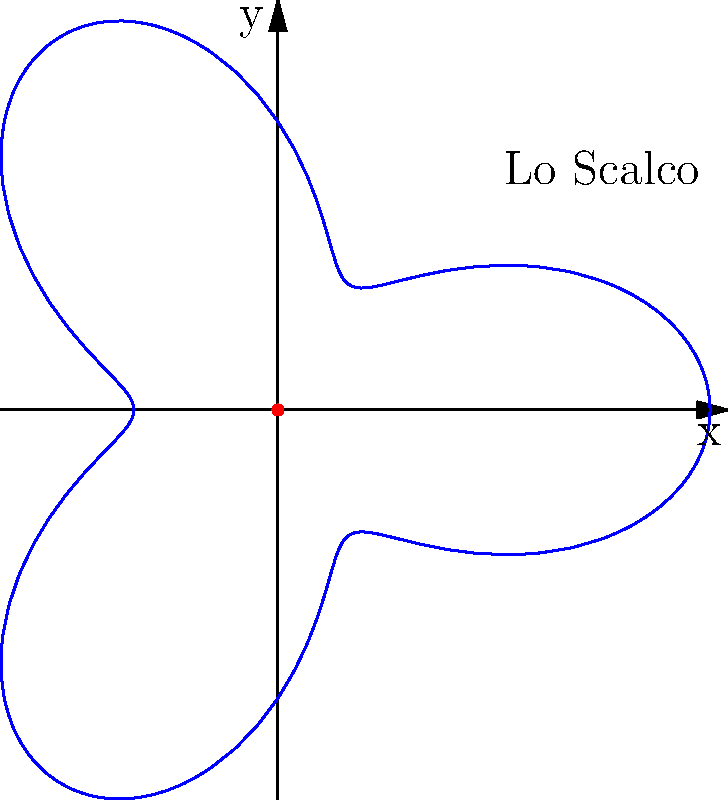Lo Scalco has implemented a new pizza delivery drone system. The path of the drone is described by the polar equation $r = 2 + \cos(3\theta)$, where $r$ is in kilometers. If the drone makes one complete revolution, what is the maximum distance it reaches from the restaurant? To find the maximum distance the drone reaches from the restaurant, we need to follow these steps:

1) The polar equation given is $r = 2 + \cos(3\theta)$.

2) The maximum value of $\cos(3\theta)$ is 1, which occurs when $3\theta = 0, 2\pi, 4\pi, ...$

3) When $\cos(3\theta) = 1$, the equation becomes:
   $r_{max} = 2 + 1 = 3$

4) Therefore, the maximum distance the drone reaches is 3 kilometers from the restaurant.

5) This occurs at angles where $\theta = 0, \frac{2\pi}{3}, \frac{4\pi}{3}$, etc.

6) The minimum distance would be when $\cos(3\theta) = -1$, giving $r_{min} = 2 - 1 = 1$ km.

7) The drone's path forms a three-leaved rose curve, with three maximum points at 3 km and three minimum points at 1 km from the restaurant.
Answer: 3 kilometers 